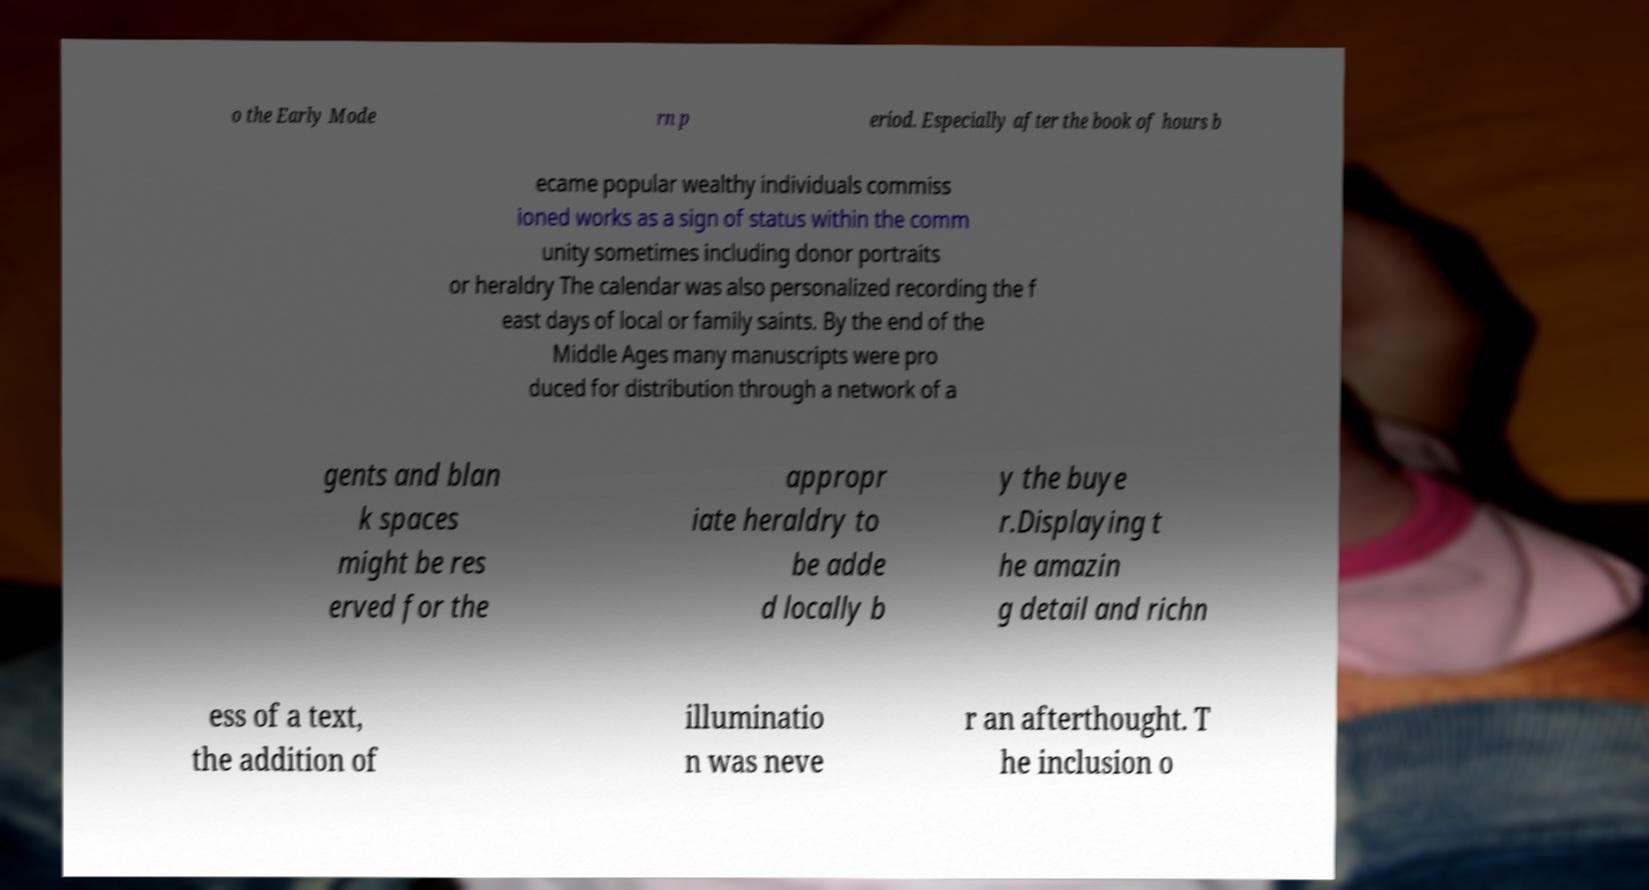Please read and relay the text visible in this image. What does it say? o the Early Mode rn p eriod. Especially after the book of hours b ecame popular wealthy individuals commiss ioned works as a sign of status within the comm unity sometimes including donor portraits or heraldry The calendar was also personalized recording the f east days of local or family saints. By the end of the Middle Ages many manuscripts were pro duced for distribution through a network of a gents and blan k spaces might be res erved for the appropr iate heraldry to be adde d locally b y the buye r.Displaying t he amazin g detail and richn ess of a text, the addition of illuminatio n was neve r an afterthought. T he inclusion o 